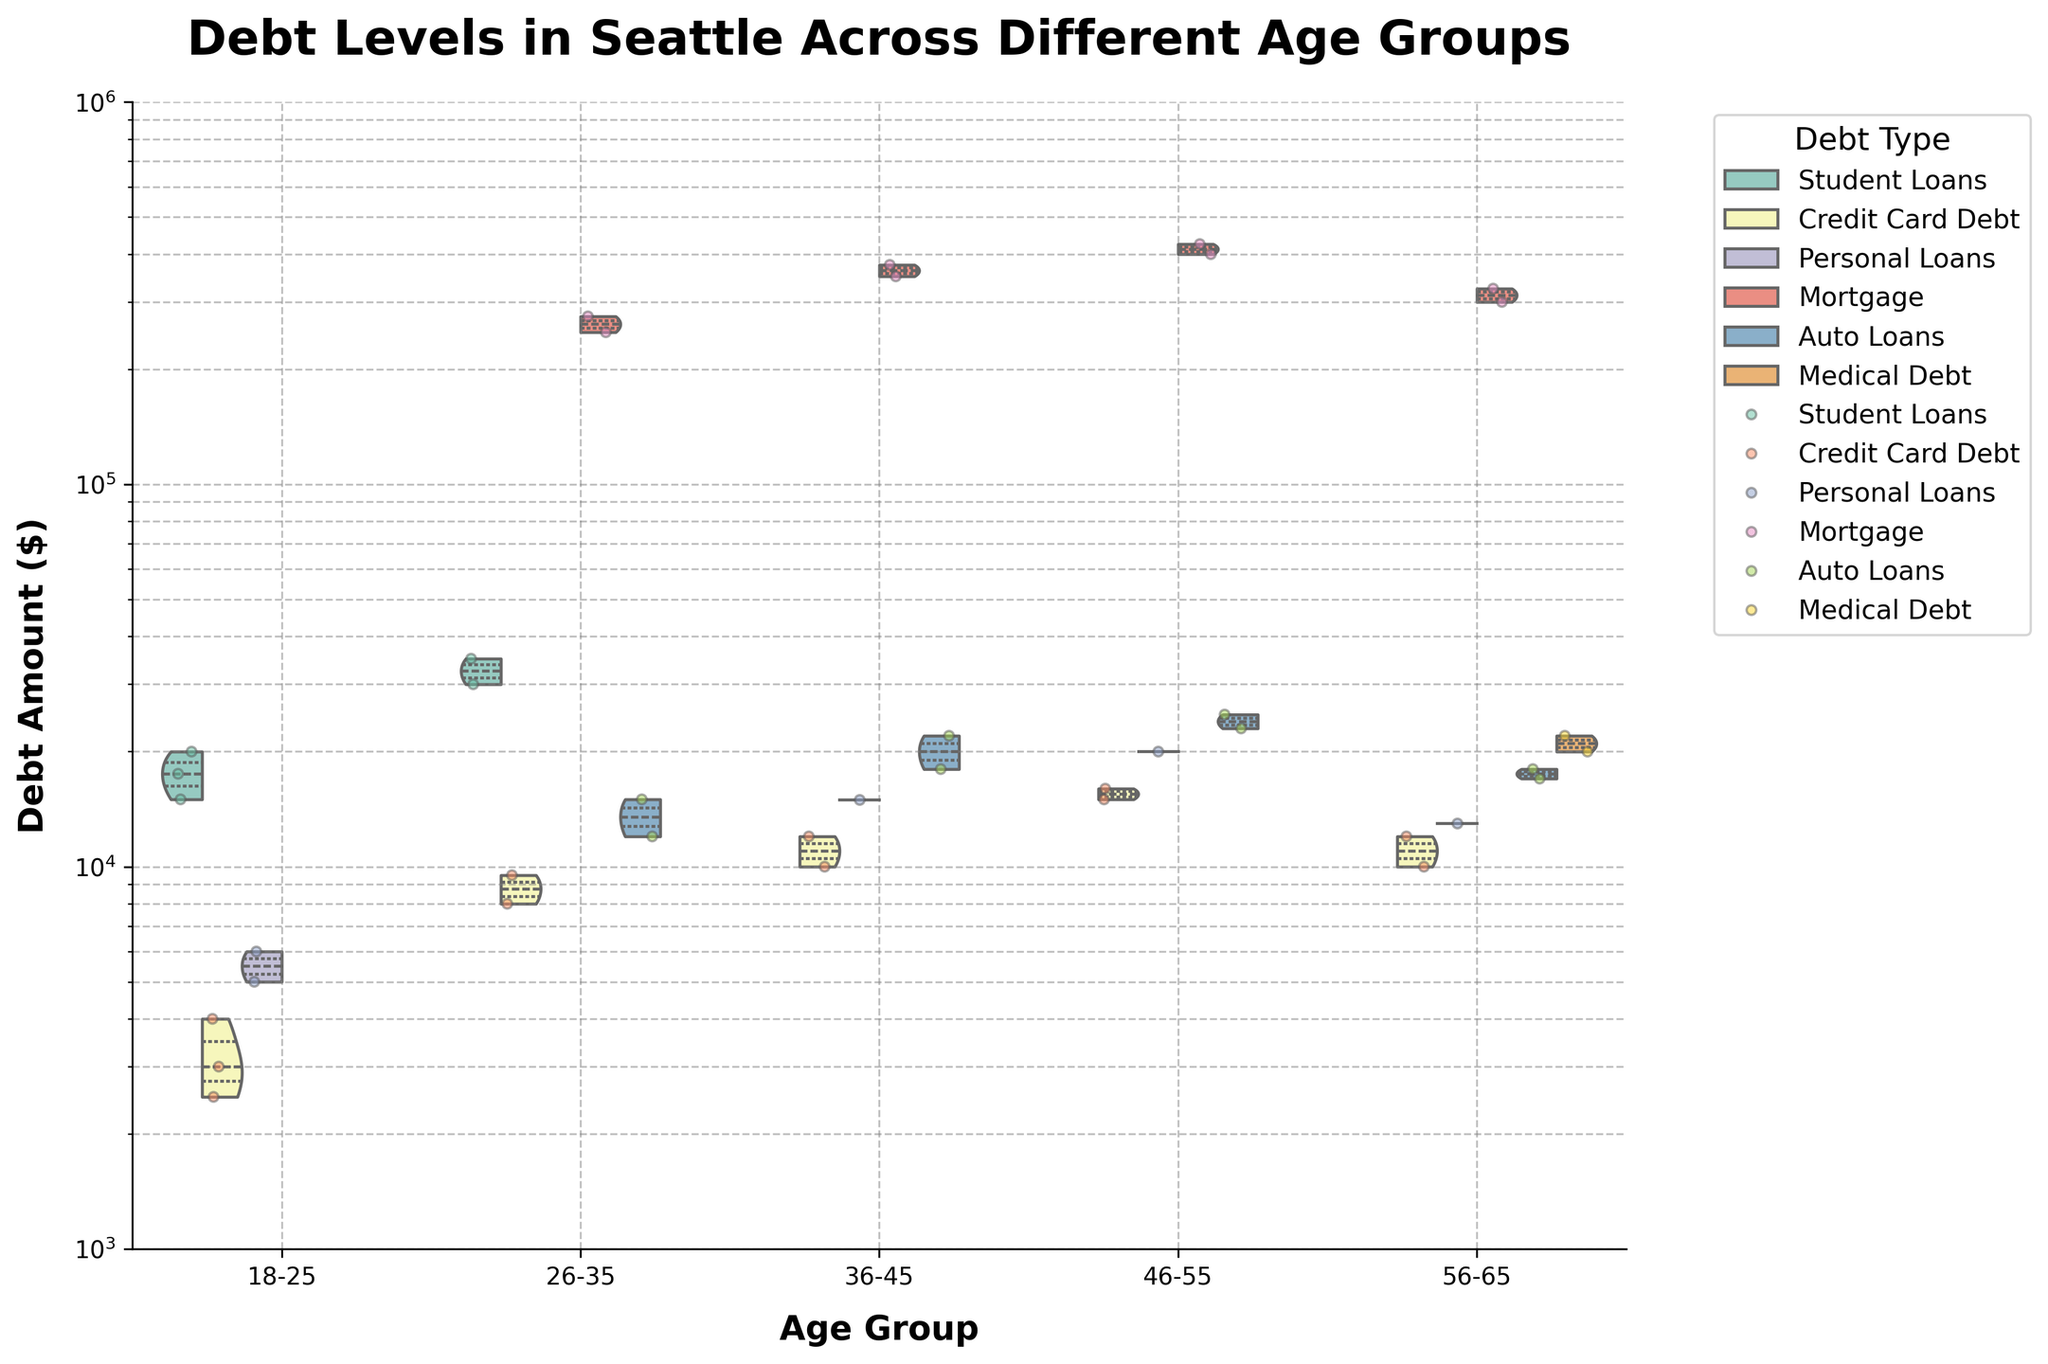what is the title of the figure? The title is prominently displayed at the top of the figure. It provides a summary of what the chart is depicting.
Answer: Debt Levels in Seattle Across Different Age Groups Which age group has the highest maximum debt amount? By comparing the highest points on each age group's violin plot, the highest maximum debt amount can be observed. For age groups 36-45 and 46-55, mortgage debts are the highest. Age group 46-55 has a slightly higher maximum compared to others.
Answer: 46-55 How does the distribution of mortgage debt for age group 26-35 compare to that of age group 46-55? We need to compare the shape and spread of violin plots of the mortgage debts for these age groups. The median, quartiles, and the density of points will show the overall distribution. The 26-35 age group has a dense concentration around higher values while 46-55 shows wide distribution but high peaks.
Answer: The 26-35 group has dense concentration around median values; the 46-55 group is more spread out but still high Which debt type has the lowest amount in the 18-25 age group? By looking at the minimum points for each debt type block within the 18-25 category, we compare them. Credit Card Debt in the 18-25 age group shows the lowest minimum.
Answer: Credit Card Debt What age group has the highest variability in their debt amounts? The variability can be gauged by observing the width of the violin plots and the spread of jittered points. Wider and more spread-out plots indicate higher variability. The 46-55 age group shows the widest spread and most dispersed points.
Answer: 46-55 Is there a significant amount of medical debt in any age group? By examining each age group's distribution, look for violin plots that represent the medical debt type. The 56-65 age group has medical debt visualized, denoting its presence.
Answer: Yes, in the 56-65 age group Which age group has the smallest range of debt amounts overall? By comparing the range from the minimum to maximum values within each age group's violin plot, we determine which is the smallest. The 18-25 group's debt amounts range from the smallest minimum to maximum differences.
Answer: 18-25 Compare the distribution of student loans between the 18-25 and 26-35 age groups. Observe the shape, spread and density of the student loan violin plots for these age groups. The 18-25 group shows a narrower distribution while 26-35 has a wider spread and higher overall amounts.
Answer: 18-25 has narrower, while 26-35 has wider distribution at higher amounts What's the median debt amount of auto loans in the 36-45 age group? By identifying the internal quartile lines within the violin plot specific to auto loans in the 36-45 age group, the median value can be pinpointed. These lines are usually present inside the plot.
Answer: Around $20,000 